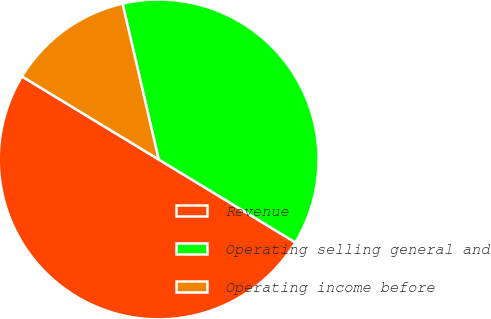Convert chart to OTSL. <chart><loc_0><loc_0><loc_500><loc_500><pie_chart><fcel>Revenue<fcel>Operating selling general and<fcel>Operating income before<nl><fcel>50.0%<fcel>37.31%<fcel>12.69%<nl></chart> 